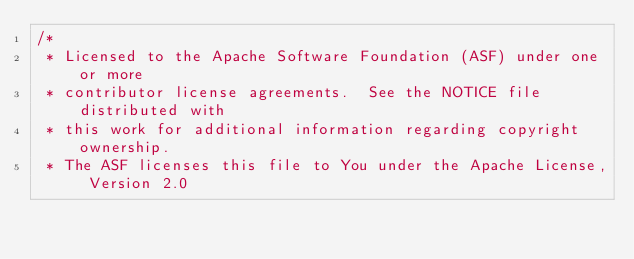<code> <loc_0><loc_0><loc_500><loc_500><_Java_>/*
 * Licensed to the Apache Software Foundation (ASF) under one or more
 * contributor license agreements.  See the NOTICE file distributed with
 * this work for additional information regarding copyright ownership.
 * The ASF licenses this file to You under the Apache License, Version 2.0</code> 